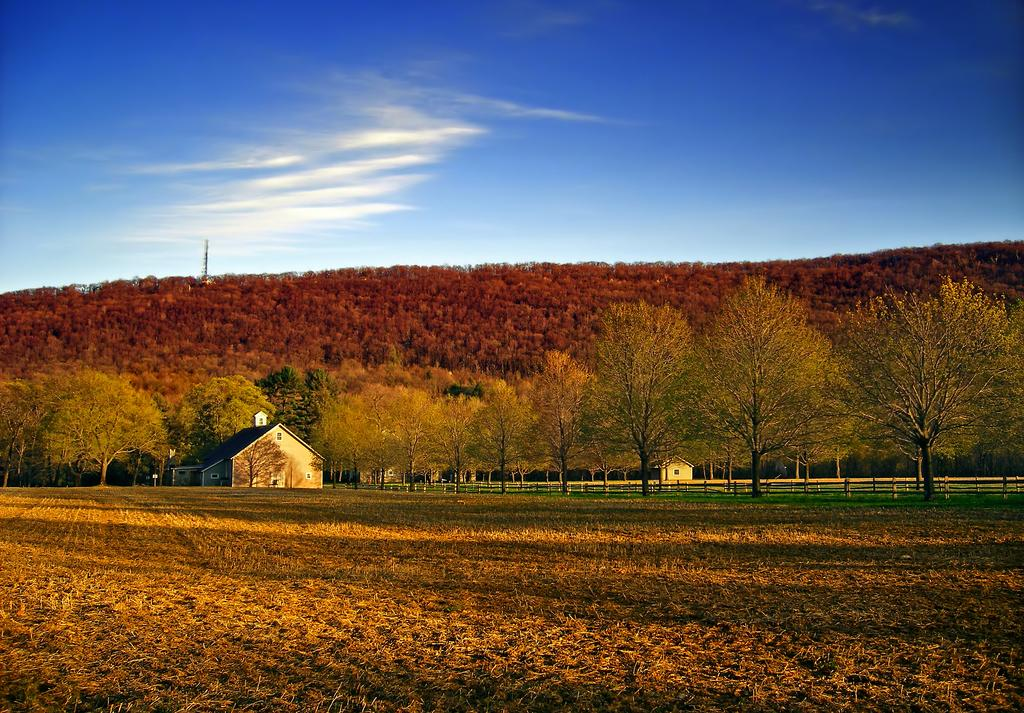What type of vegetation is at the bottom of the image? There is grass at the bottom of the image. What can be seen in the middle of the image? There are trees and houses in the middle of the image. What is the terrain feature in the middle of the image? There is a hill in the middle of the image. What is visible in the sky at the top of the image? There are clouds in the sky at the top of the image. Can you hear the music playing in the background of the image? There is no mention of music or any sound in the image, so it cannot be heard. How many dimes are scattered on the grass in the image? There are no dimes present in the image; it features grass, trees, houses, a hill, and clouds. 